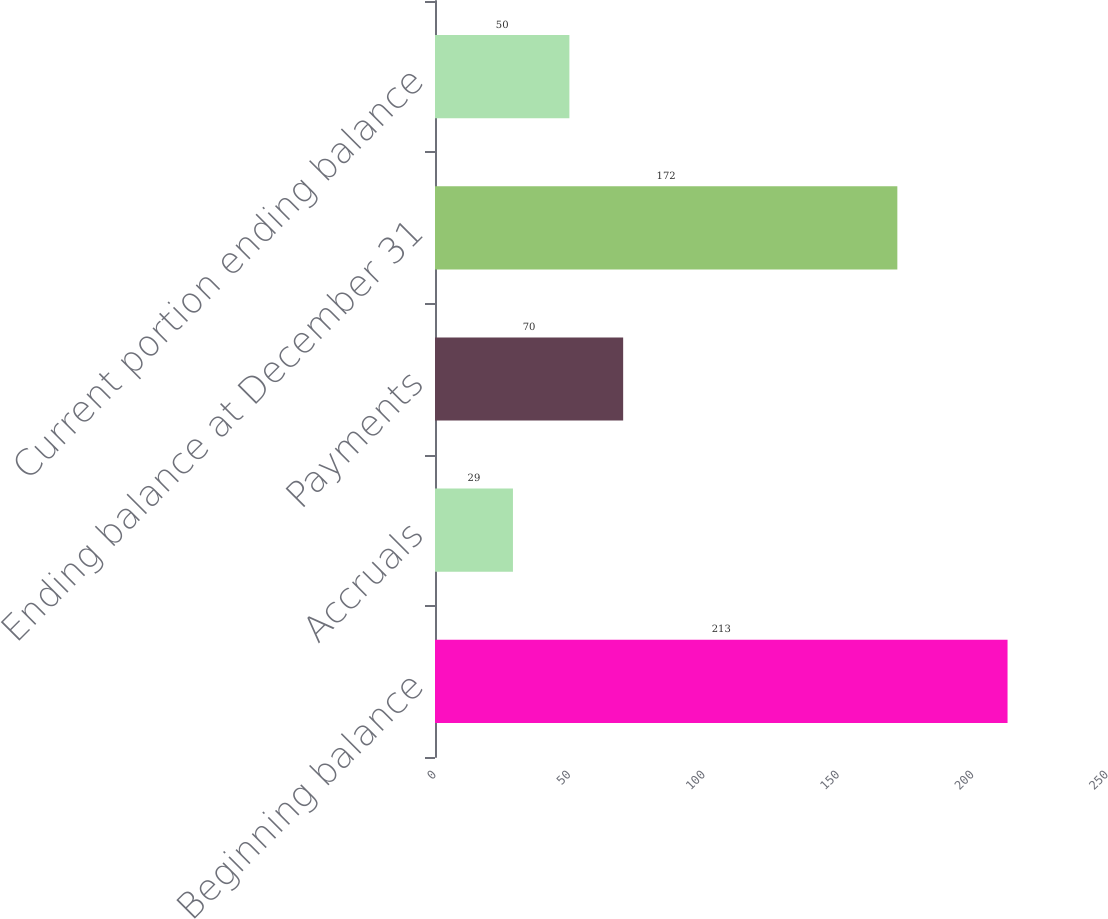Convert chart. <chart><loc_0><loc_0><loc_500><loc_500><bar_chart><fcel>Beginning balance<fcel>Accruals<fcel>Payments<fcel>Ending balance at December 31<fcel>Current portion ending balance<nl><fcel>213<fcel>29<fcel>70<fcel>172<fcel>50<nl></chart> 